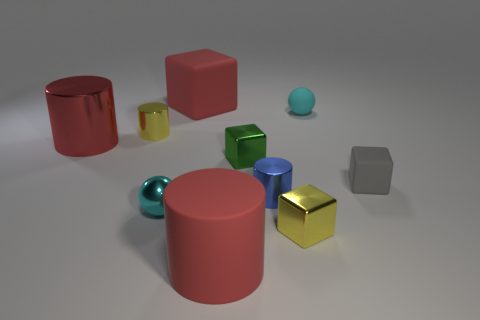There is a metal thing that is both right of the big metal cylinder and left of the small metallic sphere; how big is it?
Offer a terse response. Small. How many large blocks are there?
Give a very brief answer. 1. There is a green cube that is the same size as the cyan rubber object; what is its material?
Provide a succinct answer. Metal. Is there a cyan thing that has the same size as the gray block?
Give a very brief answer. Yes. There is a big matte object that is behind the tiny green object; is it the same color as the small cylinder that is right of the large red matte cube?
Your answer should be very brief. No. How many rubber objects are either cyan things or blocks?
Keep it short and to the point. 3. There is a metal cylinder right of the large matte object behind the tiny cyan shiny object; what number of small metal cubes are to the left of it?
Offer a very short reply. 1. There is a gray block that is the same material as the big red block; what is its size?
Provide a short and direct response. Small. How many big metallic cylinders are the same color as the tiny rubber block?
Offer a terse response. 0. Do the red matte thing behind the red metallic object and the large matte cylinder have the same size?
Your answer should be compact. Yes. 